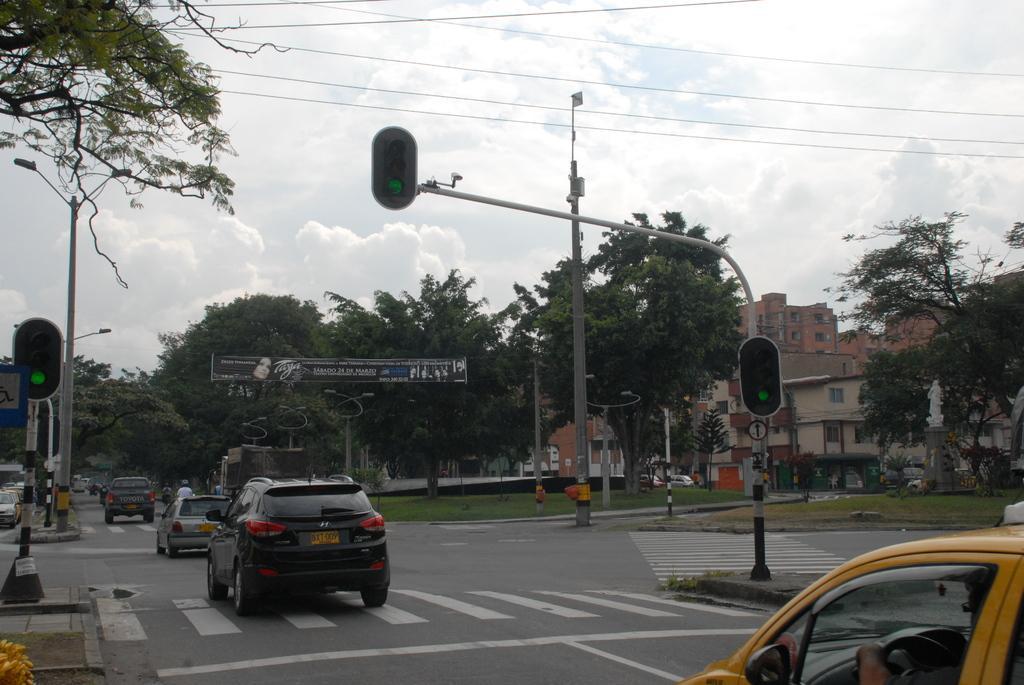How would you summarize this image in a sentence or two? In the image in the center, we can see a few vehicles on the road. And we can see poles and sign boards. In the background, we can see the sky, clouds, trees, buildings, grass, few people etc. 